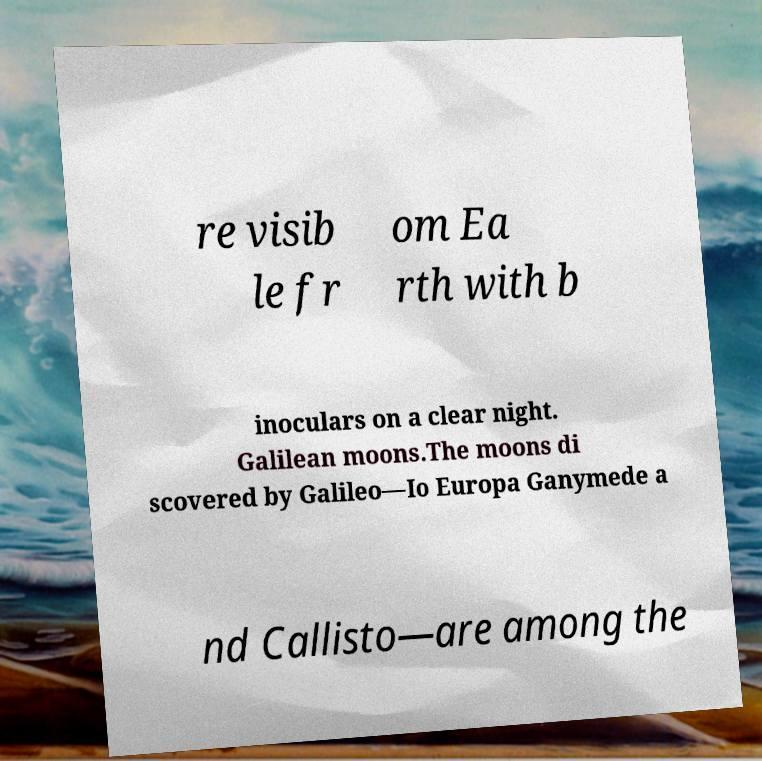Could you extract and type out the text from this image? re visib le fr om Ea rth with b inoculars on a clear night. Galilean moons.The moons di scovered by Galileo—Io Europa Ganymede a nd Callisto—are among the 